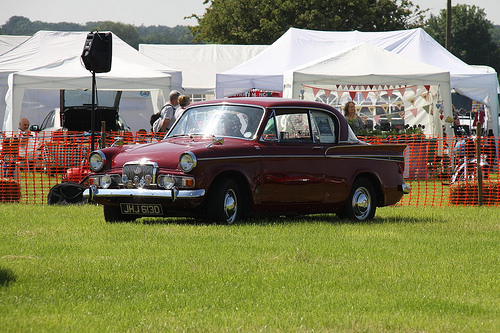<image>
Is the speaker on the car? No. The speaker is not positioned on the car. They may be near each other, but the speaker is not supported by or resting on top of the car. Where is the fence in relation to the car? Is it behind the car? Yes. From this viewpoint, the fence is positioned behind the car, with the car partially or fully occluding the fence. 